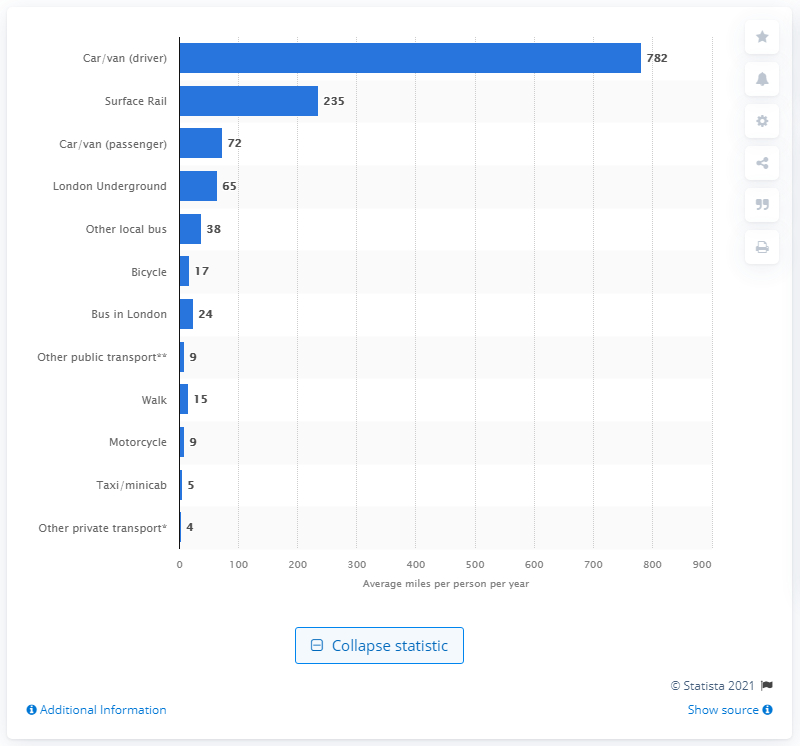Point out several critical features in this image. The total annual mileage driven by car and van drivers was 782 miles per person. 